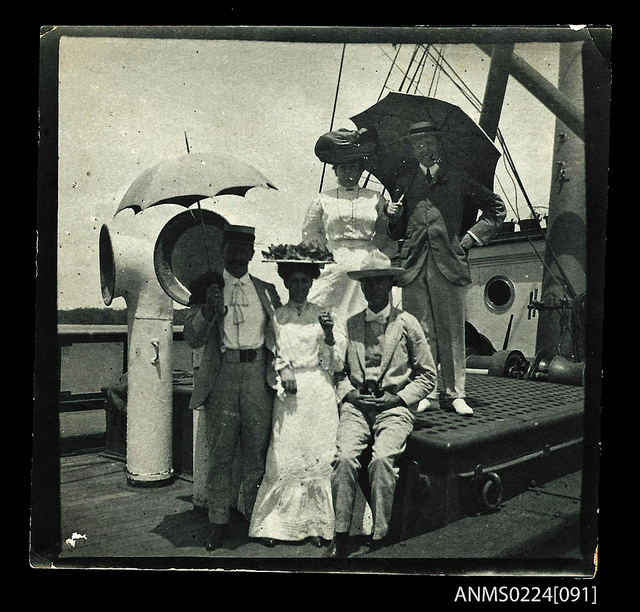Identify and read out the text in this image. ANMS0224[091] 